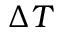<formula> <loc_0><loc_0><loc_500><loc_500>\Delta T</formula> 